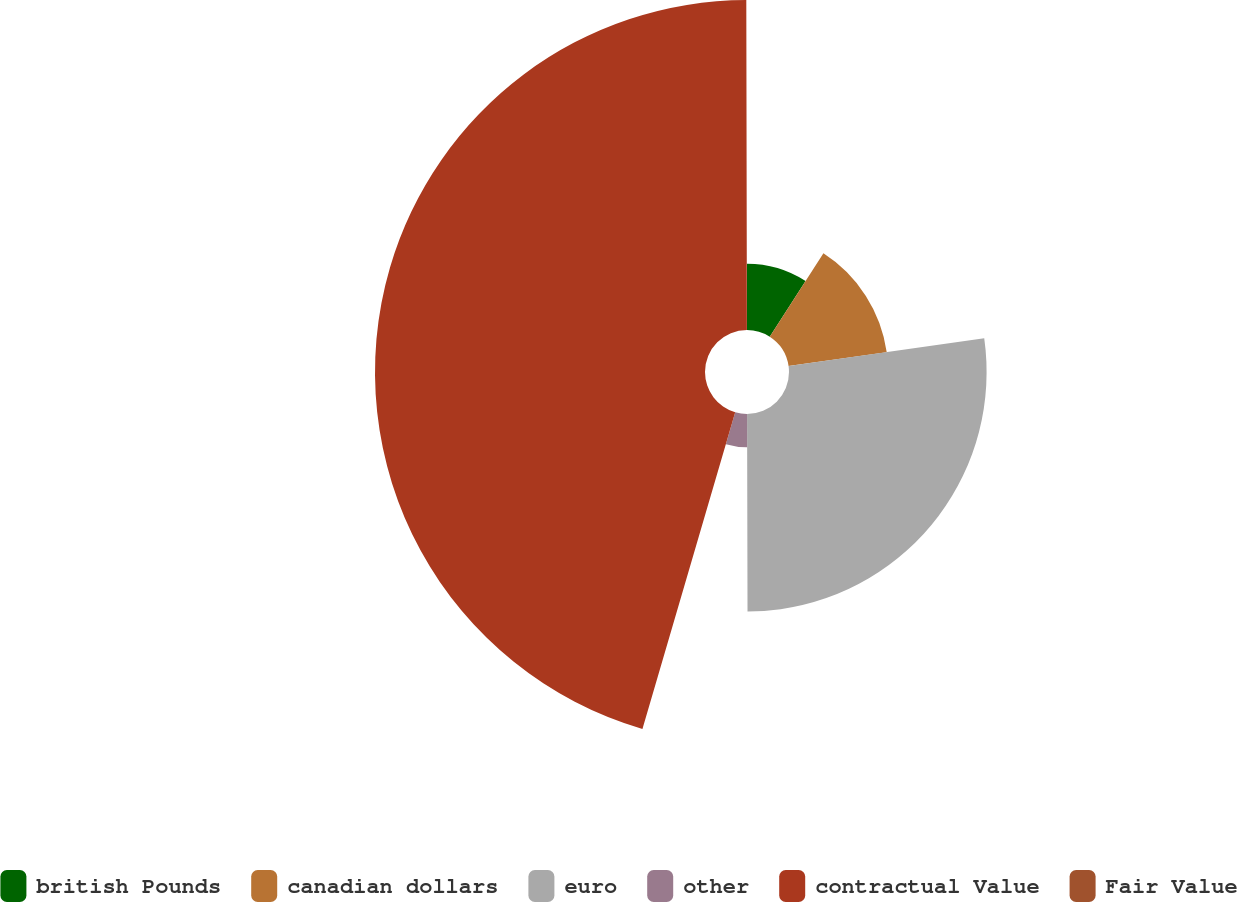Convert chart to OTSL. <chart><loc_0><loc_0><loc_500><loc_500><pie_chart><fcel>british Pounds<fcel>canadian dollars<fcel>euro<fcel>other<fcel>contractual Value<fcel>Fair Value<nl><fcel>9.11%<fcel>13.65%<fcel>27.21%<fcel>4.57%<fcel>45.44%<fcel>0.03%<nl></chart> 